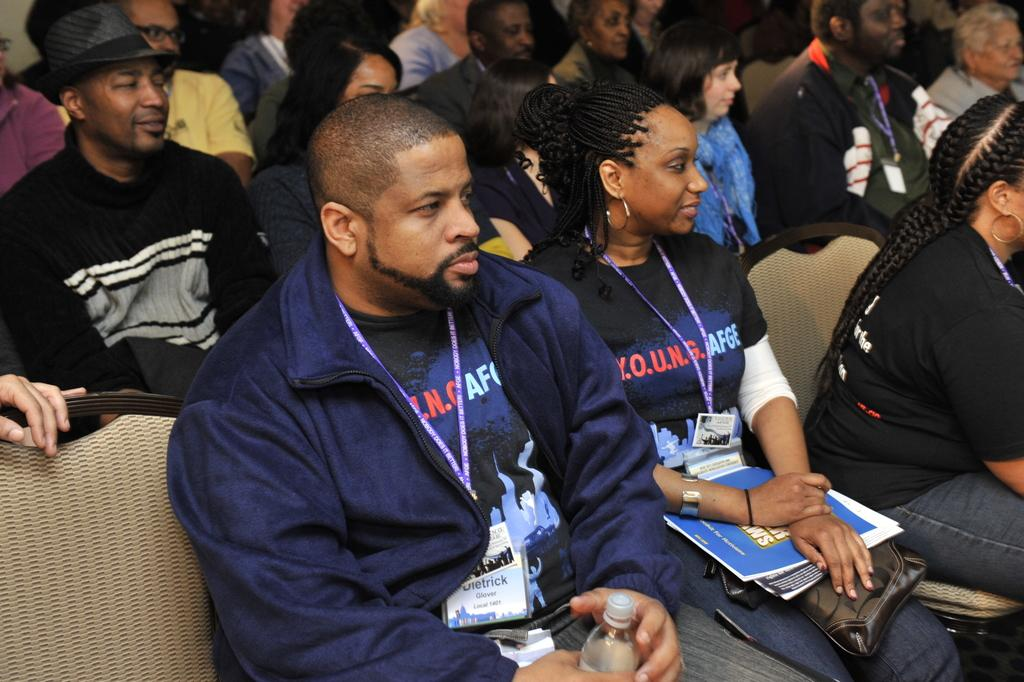How many people are in the image? There are people in the image, but the exact number is not specified. What are the people doing in the image? The people are sitting on chairs in the image. What type of watch is the grandmother wearing in the image? There is no mention of a grandmother or a watch in the image, so this information cannot be provided. 